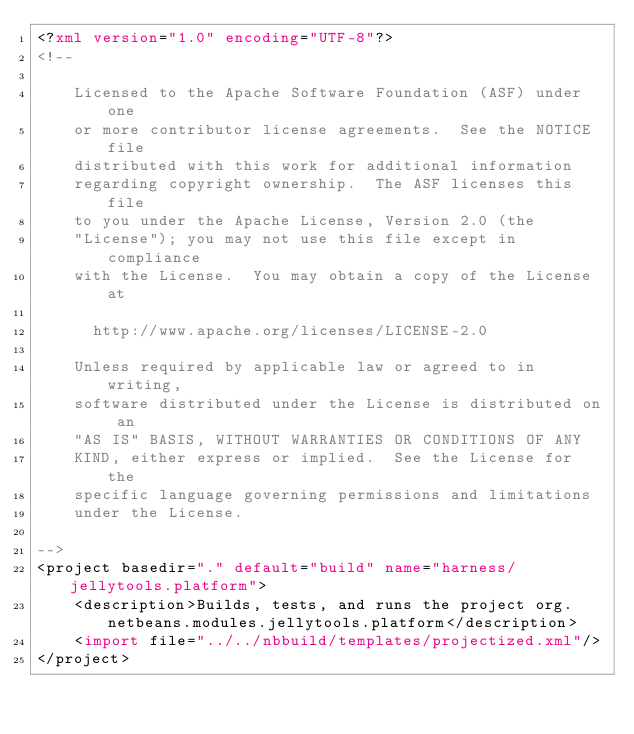Convert code to text. <code><loc_0><loc_0><loc_500><loc_500><_XML_><?xml version="1.0" encoding="UTF-8"?>
<!--

    Licensed to the Apache Software Foundation (ASF) under one
    or more contributor license agreements.  See the NOTICE file
    distributed with this work for additional information
    regarding copyright ownership.  The ASF licenses this file
    to you under the Apache License, Version 2.0 (the
    "License"); you may not use this file except in compliance
    with the License.  You may obtain a copy of the License at

      http://www.apache.org/licenses/LICENSE-2.0

    Unless required by applicable law or agreed to in writing,
    software distributed under the License is distributed on an
    "AS IS" BASIS, WITHOUT WARRANTIES OR CONDITIONS OF ANY
    KIND, either express or implied.  See the License for the
    specific language governing permissions and limitations
    under the License.

-->
<project basedir="." default="build" name="harness/jellytools.platform">
    <description>Builds, tests, and runs the project org.netbeans.modules.jellytools.platform</description>
    <import file="../../nbbuild/templates/projectized.xml"/>
</project>
</code> 